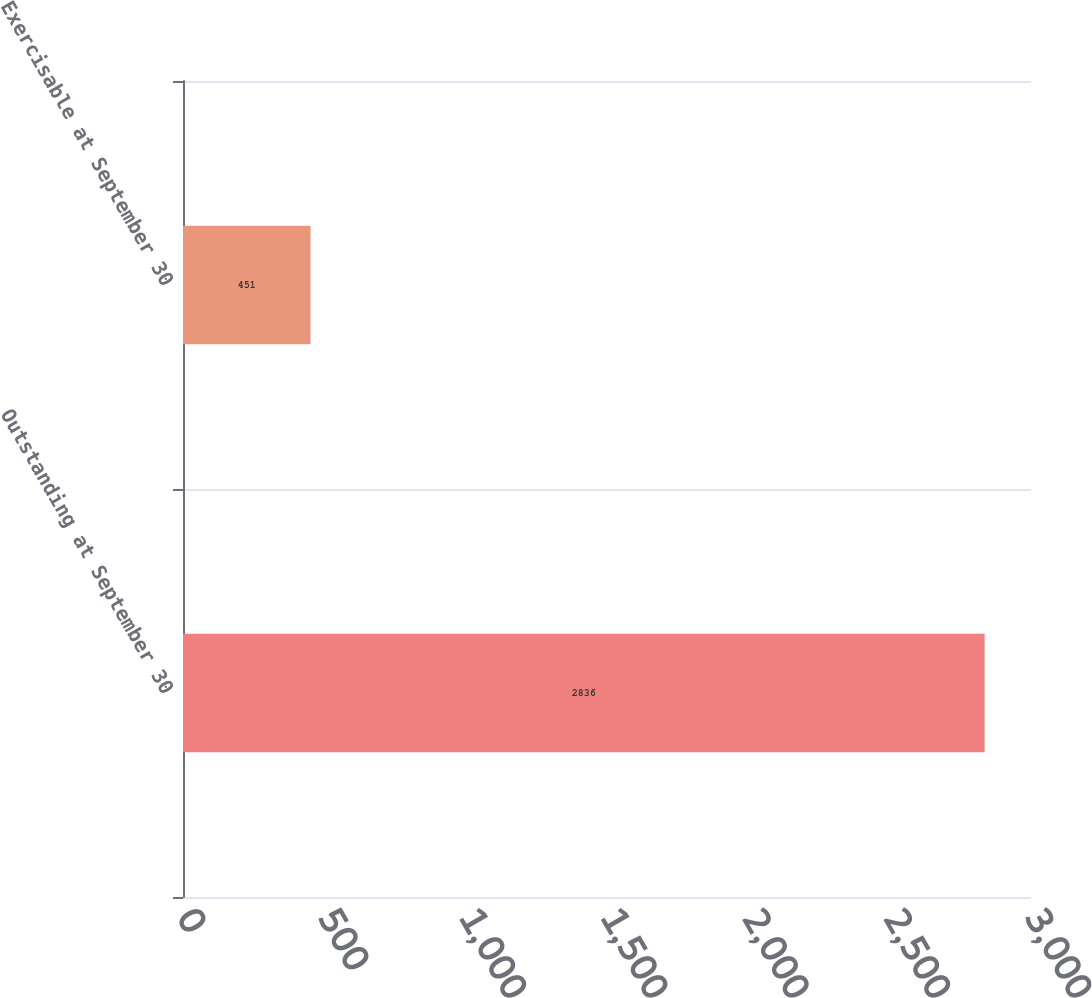<chart> <loc_0><loc_0><loc_500><loc_500><bar_chart><fcel>Outstanding at September 30<fcel>Exercisable at September 30<nl><fcel>2836<fcel>451<nl></chart> 